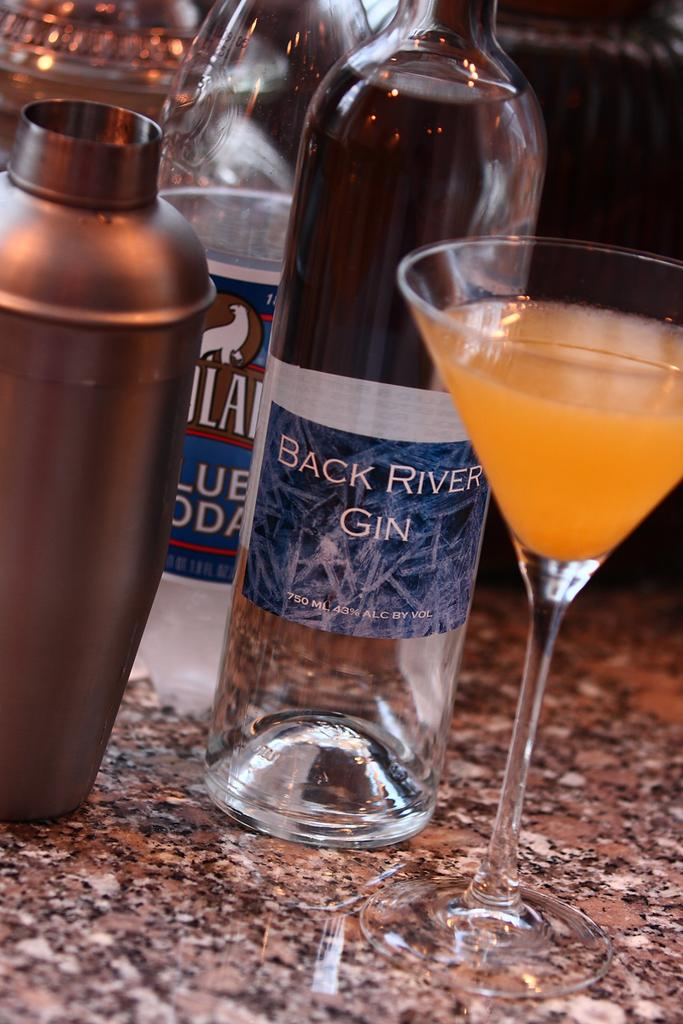<image>
Create a compact narrative representing the image presented. A bottle of "BACK RIVER GIN" is on the table. 